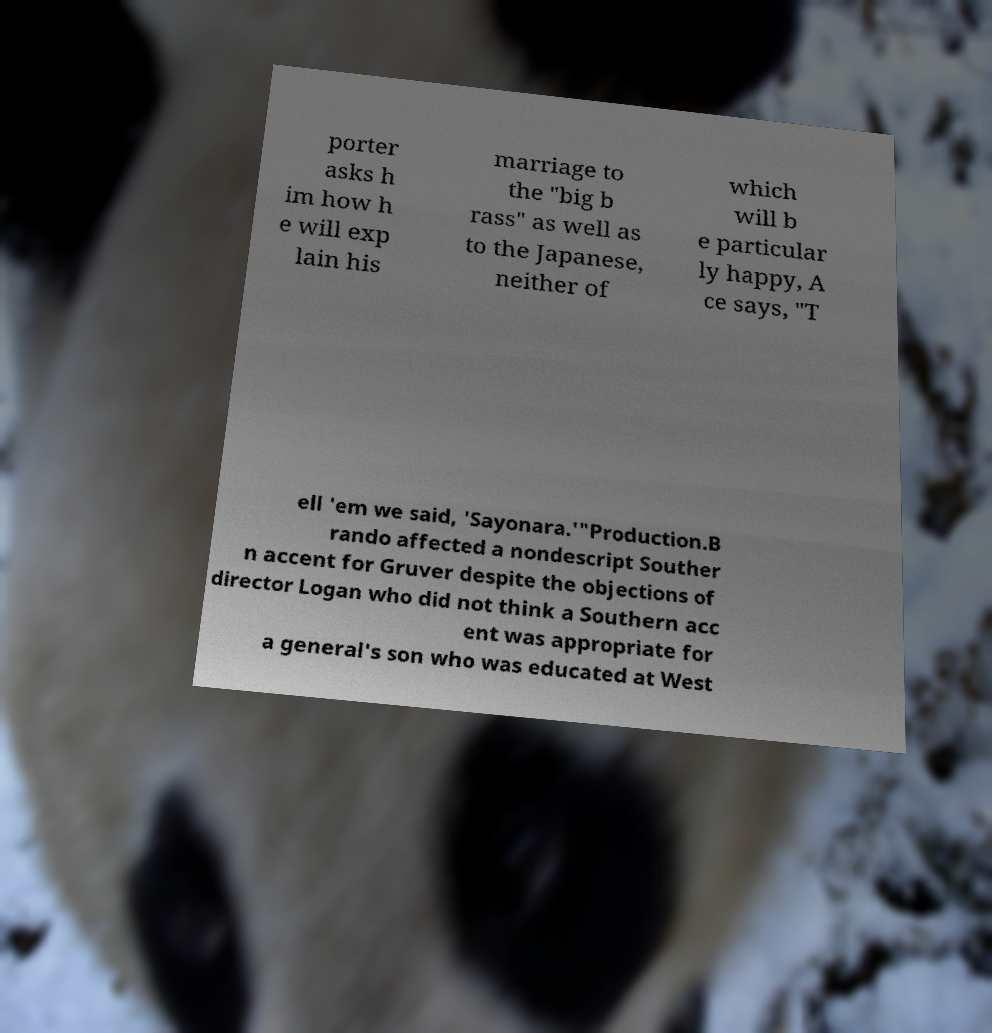What messages or text are displayed in this image? I need them in a readable, typed format. porter asks h im how h e will exp lain his marriage to the "big b rass" as well as to the Japanese, neither of which will b e particular ly happy, A ce says, "T ell 'em we said, 'Sayonara.'"Production.B rando affected a nondescript Souther n accent for Gruver despite the objections of director Logan who did not think a Southern acc ent was appropriate for a general's son who was educated at West 